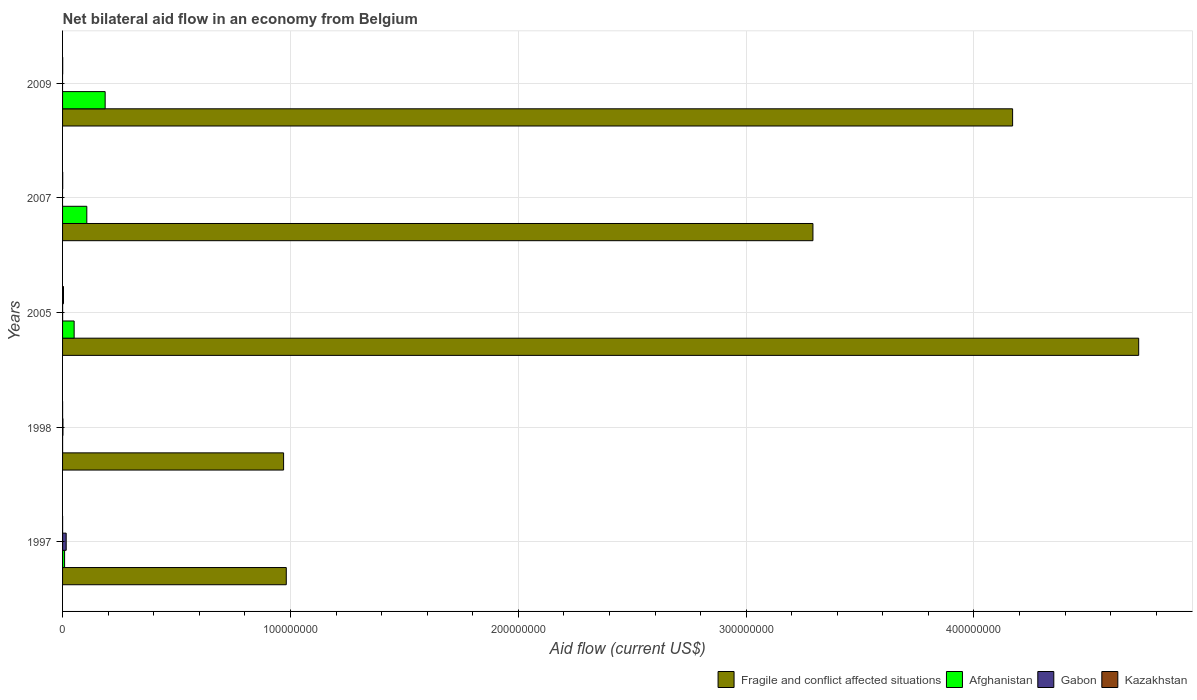Are the number of bars on each tick of the Y-axis equal?
Your answer should be very brief. No. How many bars are there on the 4th tick from the top?
Offer a terse response. 4. How many bars are there on the 2nd tick from the bottom?
Offer a terse response. 4. What is the net bilateral aid flow in Fragile and conflict affected situations in 1998?
Your answer should be very brief. 9.70e+07. Across all years, what is the maximum net bilateral aid flow in Kazakhstan?
Offer a terse response. 4.10e+05. What is the total net bilateral aid flow in Gabon in the graph?
Your answer should be compact. 1.78e+06. What is the difference between the net bilateral aid flow in Kazakhstan in 2007 and that in 2009?
Offer a terse response. 10000. What is the difference between the net bilateral aid flow in Kazakhstan in 2005 and the net bilateral aid flow in Afghanistan in 1997?
Keep it short and to the point. -4.80e+05. What is the average net bilateral aid flow in Fragile and conflict affected situations per year?
Keep it short and to the point. 2.83e+08. In the year 2009, what is the difference between the net bilateral aid flow in Afghanistan and net bilateral aid flow in Fragile and conflict affected situations?
Provide a short and direct response. -3.98e+08. In how many years, is the net bilateral aid flow in Kazakhstan greater than 100000000 US$?
Your response must be concise. 0. Is the difference between the net bilateral aid flow in Afghanistan in 1997 and 1998 greater than the difference between the net bilateral aid flow in Fragile and conflict affected situations in 1997 and 1998?
Your answer should be very brief. No. What is the difference between the highest and the second highest net bilateral aid flow in Fragile and conflict affected situations?
Ensure brevity in your answer.  5.53e+07. What is the difference between the highest and the lowest net bilateral aid flow in Kazakhstan?
Provide a short and direct response. 4.00e+05. Is the sum of the net bilateral aid flow in Kazakhstan in 1998 and 2007 greater than the maximum net bilateral aid flow in Fragile and conflict affected situations across all years?
Your answer should be very brief. No. Is it the case that in every year, the sum of the net bilateral aid flow in Afghanistan and net bilateral aid flow in Fragile and conflict affected situations is greater than the net bilateral aid flow in Kazakhstan?
Make the answer very short. Yes. How many bars are there?
Provide a short and direct response. 18. What is the difference between two consecutive major ticks on the X-axis?
Provide a succinct answer. 1.00e+08. How are the legend labels stacked?
Your response must be concise. Horizontal. What is the title of the graph?
Your answer should be very brief. Net bilateral aid flow in an economy from Belgium. Does "Maldives" appear as one of the legend labels in the graph?
Offer a very short reply. No. What is the label or title of the X-axis?
Ensure brevity in your answer.  Aid flow (current US$). What is the label or title of the Y-axis?
Offer a terse response. Years. What is the Aid flow (current US$) of Fragile and conflict affected situations in 1997?
Your answer should be compact. 9.82e+07. What is the Aid flow (current US$) in Afghanistan in 1997?
Give a very brief answer. 8.90e+05. What is the Aid flow (current US$) of Gabon in 1997?
Keep it short and to the point. 1.59e+06. What is the Aid flow (current US$) in Fragile and conflict affected situations in 1998?
Give a very brief answer. 9.70e+07. What is the Aid flow (current US$) in Afghanistan in 1998?
Your answer should be compact. 10000. What is the Aid flow (current US$) in Fragile and conflict affected situations in 2005?
Your answer should be very brief. 4.72e+08. What is the Aid flow (current US$) of Afghanistan in 2005?
Your answer should be very brief. 5.08e+06. What is the Aid flow (current US$) of Fragile and conflict affected situations in 2007?
Your answer should be compact. 3.29e+08. What is the Aid flow (current US$) of Afghanistan in 2007?
Provide a short and direct response. 1.06e+07. What is the Aid flow (current US$) in Fragile and conflict affected situations in 2009?
Keep it short and to the point. 4.17e+08. What is the Aid flow (current US$) of Afghanistan in 2009?
Ensure brevity in your answer.  1.87e+07. What is the Aid flow (current US$) in Kazakhstan in 2009?
Your answer should be very brief. 5.00e+04. Across all years, what is the maximum Aid flow (current US$) in Fragile and conflict affected situations?
Your answer should be very brief. 4.72e+08. Across all years, what is the maximum Aid flow (current US$) in Afghanistan?
Provide a succinct answer. 1.87e+07. Across all years, what is the maximum Aid flow (current US$) in Gabon?
Your answer should be compact. 1.59e+06. Across all years, what is the minimum Aid flow (current US$) of Fragile and conflict affected situations?
Give a very brief answer. 9.70e+07. Across all years, what is the minimum Aid flow (current US$) in Afghanistan?
Keep it short and to the point. 10000. Across all years, what is the minimum Aid flow (current US$) of Gabon?
Your response must be concise. 0. What is the total Aid flow (current US$) of Fragile and conflict affected situations in the graph?
Your answer should be very brief. 1.41e+09. What is the total Aid flow (current US$) of Afghanistan in the graph?
Make the answer very short. 3.53e+07. What is the total Aid flow (current US$) of Gabon in the graph?
Offer a terse response. 1.78e+06. What is the total Aid flow (current US$) of Kazakhstan in the graph?
Offer a terse response. 5.40e+05. What is the difference between the Aid flow (current US$) of Fragile and conflict affected situations in 1997 and that in 1998?
Your answer should be very brief. 1.18e+06. What is the difference between the Aid flow (current US$) of Afghanistan in 1997 and that in 1998?
Provide a succinct answer. 8.80e+05. What is the difference between the Aid flow (current US$) in Gabon in 1997 and that in 1998?
Provide a succinct answer. 1.42e+06. What is the difference between the Aid flow (current US$) of Kazakhstan in 1997 and that in 1998?
Provide a short and direct response. 0. What is the difference between the Aid flow (current US$) in Fragile and conflict affected situations in 1997 and that in 2005?
Keep it short and to the point. -3.74e+08. What is the difference between the Aid flow (current US$) in Afghanistan in 1997 and that in 2005?
Provide a short and direct response. -4.19e+06. What is the difference between the Aid flow (current US$) in Gabon in 1997 and that in 2005?
Provide a short and direct response. 1.57e+06. What is the difference between the Aid flow (current US$) in Kazakhstan in 1997 and that in 2005?
Keep it short and to the point. -4.00e+05. What is the difference between the Aid flow (current US$) of Fragile and conflict affected situations in 1997 and that in 2007?
Ensure brevity in your answer.  -2.31e+08. What is the difference between the Aid flow (current US$) in Afghanistan in 1997 and that in 2007?
Offer a terse response. -9.75e+06. What is the difference between the Aid flow (current US$) of Fragile and conflict affected situations in 1997 and that in 2009?
Your response must be concise. -3.19e+08. What is the difference between the Aid flow (current US$) in Afghanistan in 1997 and that in 2009?
Provide a short and direct response. -1.78e+07. What is the difference between the Aid flow (current US$) of Kazakhstan in 1997 and that in 2009?
Keep it short and to the point. -4.00e+04. What is the difference between the Aid flow (current US$) of Fragile and conflict affected situations in 1998 and that in 2005?
Keep it short and to the point. -3.75e+08. What is the difference between the Aid flow (current US$) in Afghanistan in 1998 and that in 2005?
Offer a terse response. -5.07e+06. What is the difference between the Aid flow (current US$) of Kazakhstan in 1998 and that in 2005?
Offer a very short reply. -4.00e+05. What is the difference between the Aid flow (current US$) in Fragile and conflict affected situations in 1998 and that in 2007?
Make the answer very short. -2.32e+08. What is the difference between the Aid flow (current US$) of Afghanistan in 1998 and that in 2007?
Provide a short and direct response. -1.06e+07. What is the difference between the Aid flow (current US$) of Kazakhstan in 1998 and that in 2007?
Your response must be concise. -5.00e+04. What is the difference between the Aid flow (current US$) in Fragile and conflict affected situations in 1998 and that in 2009?
Keep it short and to the point. -3.20e+08. What is the difference between the Aid flow (current US$) of Afghanistan in 1998 and that in 2009?
Offer a terse response. -1.87e+07. What is the difference between the Aid flow (current US$) of Kazakhstan in 1998 and that in 2009?
Your answer should be very brief. -4.00e+04. What is the difference between the Aid flow (current US$) of Fragile and conflict affected situations in 2005 and that in 2007?
Offer a very short reply. 1.43e+08. What is the difference between the Aid flow (current US$) in Afghanistan in 2005 and that in 2007?
Make the answer very short. -5.56e+06. What is the difference between the Aid flow (current US$) in Kazakhstan in 2005 and that in 2007?
Your response must be concise. 3.50e+05. What is the difference between the Aid flow (current US$) in Fragile and conflict affected situations in 2005 and that in 2009?
Make the answer very short. 5.53e+07. What is the difference between the Aid flow (current US$) of Afghanistan in 2005 and that in 2009?
Provide a short and direct response. -1.36e+07. What is the difference between the Aid flow (current US$) of Kazakhstan in 2005 and that in 2009?
Provide a succinct answer. 3.60e+05. What is the difference between the Aid flow (current US$) of Fragile and conflict affected situations in 2007 and that in 2009?
Offer a very short reply. -8.76e+07. What is the difference between the Aid flow (current US$) in Afghanistan in 2007 and that in 2009?
Your response must be concise. -8.05e+06. What is the difference between the Aid flow (current US$) in Kazakhstan in 2007 and that in 2009?
Your answer should be very brief. 10000. What is the difference between the Aid flow (current US$) in Fragile and conflict affected situations in 1997 and the Aid flow (current US$) in Afghanistan in 1998?
Provide a succinct answer. 9.82e+07. What is the difference between the Aid flow (current US$) of Fragile and conflict affected situations in 1997 and the Aid flow (current US$) of Gabon in 1998?
Ensure brevity in your answer.  9.80e+07. What is the difference between the Aid flow (current US$) of Fragile and conflict affected situations in 1997 and the Aid flow (current US$) of Kazakhstan in 1998?
Your answer should be compact. 9.82e+07. What is the difference between the Aid flow (current US$) of Afghanistan in 1997 and the Aid flow (current US$) of Gabon in 1998?
Your answer should be very brief. 7.20e+05. What is the difference between the Aid flow (current US$) of Afghanistan in 1997 and the Aid flow (current US$) of Kazakhstan in 1998?
Provide a succinct answer. 8.80e+05. What is the difference between the Aid flow (current US$) in Gabon in 1997 and the Aid flow (current US$) in Kazakhstan in 1998?
Make the answer very short. 1.58e+06. What is the difference between the Aid flow (current US$) of Fragile and conflict affected situations in 1997 and the Aid flow (current US$) of Afghanistan in 2005?
Your answer should be very brief. 9.31e+07. What is the difference between the Aid flow (current US$) of Fragile and conflict affected situations in 1997 and the Aid flow (current US$) of Gabon in 2005?
Provide a succinct answer. 9.82e+07. What is the difference between the Aid flow (current US$) in Fragile and conflict affected situations in 1997 and the Aid flow (current US$) in Kazakhstan in 2005?
Ensure brevity in your answer.  9.78e+07. What is the difference between the Aid flow (current US$) of Afghanistan in 1997 and the Aid flow (current US$) of Gabon in 2005?
Your answer should be compact. 8.70e+05. What is the difference between the Aid flow (current US$) of Gabon in 1997 and the Aid flow (current US$) of Kazakhstan in 2005?
Keep it short and to the point. 1.18e+06. What is the difference between the Aid flow (current US$) in Fragile and conflict affected situations in 1997 and the Aid flow (current US$) in Afghanistan in 2007?
Offer a terse response. 8.75e+07. What is the difference between the Aid flow (current US$) in Fragile and conflict affected situations in 1997 and the Aid flow (current US$) in Kazakhstan in 2007?
Offer a very short reply. 9.81e+07. What is the difference between the Aid flow (current US$) of Afghanistan in 1997 and the Aid flow (current US$) of Kazakhstan in 2007?
Keep it short and to the point. 8.30e+05. What is the difference between the Aid flow (current US$) of Gabon in 1997 and the Aid flow (current US$) of Kazakhstan in 2007?
Your answer should be very brief. 1.53e+06. What is the difference between the Aid flow (current US$) in Fragile and conflict affected situations in 1997 and the Aid flow (current US$) in Afghanistan in 2009?
Provide a succinct answer. 7.95e+07. What is the difference between the Aid flow (current US$) in Fragile and conflict affected situations in 1997 and the Aid flow (current US$) in Kazakhstan in 2009?
Your answer should be compact. 9.81e+07. What is the difference between the Aid flow (current US$) of Afghanistan in 1997 and the Aid flow (current US$) of Kazakhstan in 2009?
Your answer should be very brief. 8.40e+05. What is the difference between the Aid flow (current US$) of Gabon in 1997 and the Aid flow (current US$) of Kazakhstan in 2009?
Provide a short and direct response. 1.54e+06. What is the difference between the Aid flow (current US$) of Fragile and conflict affected situations in 1998 and the Aid flow (current US$) of Afghanistan in 2005?
Offer a terse response. 9.19e+07. What is the difference between the Aid flow (current US$) in Fragile and conflict affected situations in 1998 and the Aid flow (current US$) in Gabon in 2005?
Make the answer very short. 9.70e+07. What is the difference between the Aid flow (current US$) in Fragile and conflict affected situations in 1998 and the Aid flow (current US$) in Kazakhstan in 2005?
Offer a terse response. 9.66e+07. What is the difference between the Aid flow (current US$) in Afghanistan in 1998 and the Aid flow (current US$) in Gabon in 2005?
Provide a short and direct response. -10000. What is the difference between the Aid flow (current US$) of Afghanistan in 1998 and the Aid flow (current US$) of Kazakhstan in 2005?
Offer a very short reply. -4.00e+05. What is the difference between the Aid flow (current US$) in Gabon in 1998 and the Aid flow (current US$) in Kazakhstan in 2005?
Provide a succinct answer. -2.40e+05. What is the difference between the Aid flow (current US$) in Fragile and conflict affected situations in 1998 and the Aid flow (current US$) in Afghanistan in 2007?
Your answer should be compact. 8.64e+07. What is the difference between the Aid flow (current US$) of Fragile and conflict affected situations in 1998 and the Aid flow (current US$) of Kazakhstan in 2007?
Keep it short and to the point. 9.69e+07. What is the difference between the Aid flow (current US$) of Afghanistan in 1998 and the Aid flow (current US$) of Kazakhstan in 2007?
Provide a short and direct response. -5.00e+04. What is the difference between the Aid flow (current US$) in Fragile and conflict affected situations in 1998 and the Aid flow (current US$) in Afghanistan in 2009?
Give a very brief answer. 7.83e+07. What is the difference between the Aid flow (current US$) of Fragile and conflict affected situations in 1998 and the Aid flow (current US$) of Kazakhstan in 2009?
Your answer should be compact. 9.70e+07. What is the difference between the Aid flow (current US$) in Afghanistan in 1998 and the Aid flow (current US$) in Kazakhstan in 2009?
Ensure brevity in your answer.  -4.00e+04. What is the difference between the Aid flow (current US$) of Fragile and conflict affected situations in 2005 and the Aid flow (current US$) of Afghanistan in 2007?
Your answer should be very brief. 4.62e+08. What is the difference between the Aid flow (current US$) of Fragile and conflict affected situations in 2005 and the Aid flow (current US$) of Kazakhstan in 2007?
Your answer should be compact. 4.72e+08. What is the difference between the Aid flow (current US$) in Afghanistan in 2005 and the Aid flow (current US$) in Kazakhstan in 2007?
Provide a succinct answer. 5.02e+06. What is the difference between the Aid flow (current US$) of Gabon in 2005 and the Aid flow (current US$) of Kazakhstan in 2007?
Your response must be concise. -4.00e+04. What is the difference between the Aid flow (current US$) of Fragile and conflict affected situations in 2005 and the Aid flow (current US$) of Afghanistan in 2009?
Provide a short and direct response. 4.54e+08. What is the difference between the Aid flow (current US$) of Fragile and conflict affected situations in 2005 and the Aid flow (current US$) of Kazakhstan in 2009?
Offer a terse response. 4.72e+08. What is the difference between the Aid flow (current US$) in Afghanistan in 2005 and the Aid flow (current US$) in Kazakhstan in 2009?
Offer a very short reply. 5.03e+06. What is the difference between the Aid flow (current US$) of Gabon in 2005 and the Aid flow (current US$) of Kazakhstan in 2009?
Provide a succinct answer. -3.00e+04. What is the difference between the Aid flow (current US$) of Fragile and conflict affected situations in 2007 and the Aid flow (current US$) of Afghanistan in 2009?
Offer a very short reply. 3.11e+08. What is the difference between the Aid flow (current US$) of Fragile and conflict affected situations in 2007 and the Aid flow (current US$) of Kazakhstan in 2009?
Offer a very short reply. 3.29e+08. What is the difference between the Aid flow (current US$) in Afghanistan in 2007 and the Aid flow (current US$) in Kazakhstan in 2009?
Ensure brevity in your answer.  1.06e+07. What is the average Aid flow (current US$) of Fragile and conflict affected situations per year?
Your answer should be compact. 2.83e+08. What is the average Aid flow (current US$) in Afghanistan per year?
Your response must be concise. 7.06e+06. What is the average Aid flow (current US$) of Gabon per year?
Ensure brevity in your answer.  3.56e+05. What is the average Aid flow (current US$) in Kazakhstan per year?
Offer a terse response. 1.08e+05. In the year 1997, what is the difference between the Aid flow (current US$) of Fragile and conflict affected situations and Aid flow (current US$) of Afghanistan?
Ensure brevity in your answer.  9.73e+07. In the year 1997, what is the difference between the Aid flow (current US$) of Fragile and conflict affected situations and Aid flow (current US$) of Gabon?
Your response must be concise. 9.66e+07. In the year 1997, what is the difference between the Aid flow (current US$) of Fragile and conflict affected situations and Aid flow (current US$) of Kazakhstan?
Make the answer very short. 9.82e+07. In the year 1997, what is the difference between the Aid flow (current US$) of Afghanistan and Aid flow (current US$) of Gabon?
Give a very brief answer. -7.00e+05. In the year 1997, what is the difference between the Aid flow (current US$) of Afghanistan and Aid flow (current US$) of Kazakhstan?
Your answer should be very brief. 8.80e+05. In the year 1997, what is the difference between the Aid flow (current US$) of Gabon and Aid flow (current US$) of Kazakhstan?
Your answer should be very brief. 1.58e+06. In the year 1998, what is the difference between the Aid flow (current US$) of Fragile and conflict affected situations and Aid flow (current US$) of Afghanistan?
Make the answer very short. 9.70e+07. In the year 1998, what is the difference between the Aid flow (current US$) in Fragile and conflict affected situations and Aid flow (current US$) in Gabon?
Make the answer very short. 9.68e+07. In the year 1998, what is the difference between the Aid flow (current US$) of Fragile and conflict affected situations and Aid flow (current US$) of Kazakhstan?
Your answer should be compact. 9.70e+07. In the year 2005, what is the difference between the Aid flow (current US$) of Fragile and conflict affected situations and Aid flow (current US$) of Afghanistan?
Provide a short and direct response. 4.67e+08. In the year 2005, what is the difference between the Aid flow (current US$) in Fragile and conflict affected situations and Aid flow (current US$) in Gabon?
Give a very brief answer. 4.72e+08. In the year 2005, what is the difference between the Aid flow (current US$) in Fragile and conflict affected situations and Aid flow (current US$) in Kazakhstan?
Your response must be concise. 4.72e+08. In the year 2005, what is the difference between the Aid flow (current US$) of Afghanistan and Aid flow (current US$) of Gabon?
Make the answer very short. 5.06e+06. In the year 2005, what is the difference between the Aid flow (current US$) in Afghanistan and Aid flow (current US$) in Kazakhstan?
Offer a very short reply. 4.67e+06. In the year 2005, what is the difference between the Aid flow (current US$) in Gabon and Aid flow (current US$) in Kazakhstan?
Offer a terse response. -3.90e+05. In the year 2007, what is the difference between the Aid flow (current US$) of Fragile and conflict affected situations and Aid flow (current US$) of Afghanistan?
Your response must be concise. 3.19e+08. In the year 2007, what is the difference between the Aid flow (current US$) of Fragile and conflict affected situations and Aid flow (current US$) of Kazakhstan?
Offer a very short reply. 3.29e+08. In the year 2007, what is the difference between the Aid flow (current US$) of Afghanistan and Aid flow (current US$) of Kazakhstan?
Offer a very short reply. 1.06e+07. In the year 2009, what is the difference between the Aid flow (current US$) in Fragile and conflict affected situations and Aid flow (current US$) in Afghanistan?
Your answer should be compact. 3.98e+08. In the year 2009, what is the difference between the Aid flow (current US$) in Fragile and conflict affected situations and Aid flow (current US$) in Kazakhstan?
Your answer should be very brief. 4.17e+08. In the year 2009, what is the difference between the Aid flow (current US$) in Afghanistan and Aid flow (current US$) in Kazakhstan?
Ensure brevity in your answer.  1.86e+07. What is the ratio of the Aid flow (current US$) in Fragile and conflict affected situations in 1997 to that in 1998?
Provide a succinct answer. 1.01. What is the ratio of the Aid flow (current US$) of Afghanistan in 1997 to that in 1998?
Your answer should be compact. 89. What is the ratio of the Aid flow (current US$) of Gabon in 1997 to that in 1998?
Offer a terse response. 9.35. What is the ratio of the Aid flow (current US$) in Kazakhstan in 1997 to that in 1998?
Give a very brief answer. 1. What is the ratio of the Aid flow (current US$) of Fragile and conflict affected situations in 1997 to that in 2005?
Offer a very short reply. 0.21. What is the ratio of the Aid flow (current US$) of Afghanistan in 1997 to that in 2005?
Offer a very short reply. 0.18. What is the ratio of the Aid flow (current US$) in Gabon in 1997 to that in 2005?
Your answer should be very brief. 79.5. What is the ratio of the Aid flow (current US$) of Kazakhstan in 1997 to that in 2005?
Your answer should be compact. 0.02. What is the ratio of the Aid flow (current US$) of Fragile and conflict affected situations in 1997 to that in 2007?
Your response must be concise. 0.3. What is the ratio of the Aid flow (current US$) of Afghanistan in 1997 to that in 2007?
Offer a very short reply. 0.08. What is the ratio of the Aid flow (current US$) in Fragile and conflict affected situations in 1997 to that in 2009?
Provide a short and direct response. 0.24. What is the ratio of the Aid flow (current US$) of Afghanistan in 1997 to that in 2009?
Offer a very short reply. 0.05. What is the ratio of the Aid flow (current US$) in Fragile and conflict affected situations in 1998 to that in 2005?
Provide a short and direct response. 0.21. What is the ratio of the Aid flow (current US$) of Afghanistan in 1998 to that in 2005?
Keep it short and to the point. 0. What is the ratio of the Aid flow (current US$) in Gabon in 1998 to that in 2005?
Offer a very short reply. 8.5. What is the ratio of the Aid flow (current US$) of Kazakhstan in 1998 to that in 2005?
Your answer should be compact. 0.02. What is the ratio of the Aid flow (current US$) in Fragile and conflict affected situations in 1998 to that in 2007?
Make the answer very short. 0.29. What is the ratio of the Aid flow (current US$) of Afghanistan in 1998 to that in 2007?
Keep it short and to the point. 0. What is the ratio of the Aid flow (current US$) of Fragile and conflict affected situations in 1998 to that in 2009?
Ensure brevity in your answer.  0.23. What is the ratio of the Aid flow (current US$) in Kazakhstan in 1998 to that in 2009?
Your answer should be very brief. 0.2. What is the ratio of the Aid flow (current US$) of Fragile and conflict affected situations in 2005 to that in 2007?
Offer a terse response. 1.43. What is the ratio of the Aid flow (current US$) of Afghanistan in 2005 to that in 2007?
Your answer should be compact. 0.48. What is the ratio of the Aid flow (current US$) in Kazakhstan in 2005 to that in 2007?
Provide a short and direct response. 6.83. What is the ratio of the Aid flow (current US$) in Fragile and conflict affected situations in 2005 to that in 2009?
Give a very brief answer. 1.13. What is the ratio of the Aid flow (current US$) in Afghanistan in 2005 to that in 2009?
Offer a very short reply. 0.27. What is the ratio of the Aid flow (current US$) in Kazakhstan in 2005 to that in 2009?
Provide a short and direct response. 8.2. What is the ratio of the Aid flow (current US$) of Fragile and conflict affected situations in 2007 to that in 2009?
Your response must be concise. 0.79. What is the ratio of the Aid flow (current US$) in Afghanistan in 2007 to that in 2009?
Your response must be concise. 0.57. What is the ratio of the Aid flow (current US$) of Kazakhstan in 2007 to that in 2009?
Keep it short and to the point. 1.2. What is the difference between the highest and the second highest Aid flow (current US$) in Fragile and conflict affected situations?
Provide a succinct answer. 5.53e+07. What is the difference between the highest and the second highest Aid flow (current US$) of Afghanistan?
Ensure brevity in your answer.  8.05e+06. What is the difference between the highest and the second highest Aid flow (current US$) in Gabon?
Offer a very short reply. 1.42e+06. What is the difference between the highest and the lowest Aid flow (current US$) in Fragile and conflict affected situations?
Give a very brief answer. 3.75e+08. What is the difference between the highest and the lowest Aid flow (current US$) of Afghanistan?
Provide a short and direct response. 1.87e+07. What is the difference between the highest and the lowest Aid flow (current US$) in Gabon?
Your answer should be compact. 1.59e+06. 